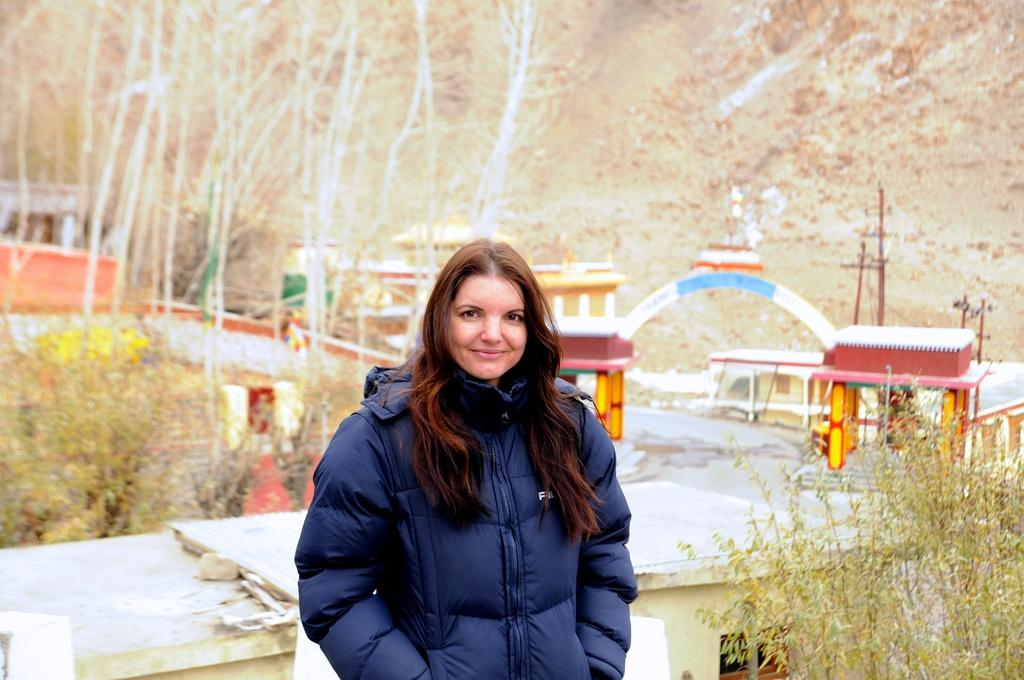Who is the main subject in the image? There is a woman in the image. What is the woman wearing? The woman is wearing a blue jacket. What can be seen in the background of the image? There are small houses in the background of the image. What type of vegetation is present to the right of the image? There are plants to the right of the image. Reasoning: Let's think step by following the guidelines to produce the conversation. We start by identifying the main subject in the image, which is the woman. Then, we describe her clothing, focusing on the blue jacket. Next, we expand the conversation to include the background and the plants on the right side of the image. Each question is designed to elicit a specific detail about the image that is known from the provided facts. Absurd Question/Answer: Can you see any berries on the plants in the image? There is no mention of berries or any specific type of plant in the image, so it cannot be determined if berries are present. 